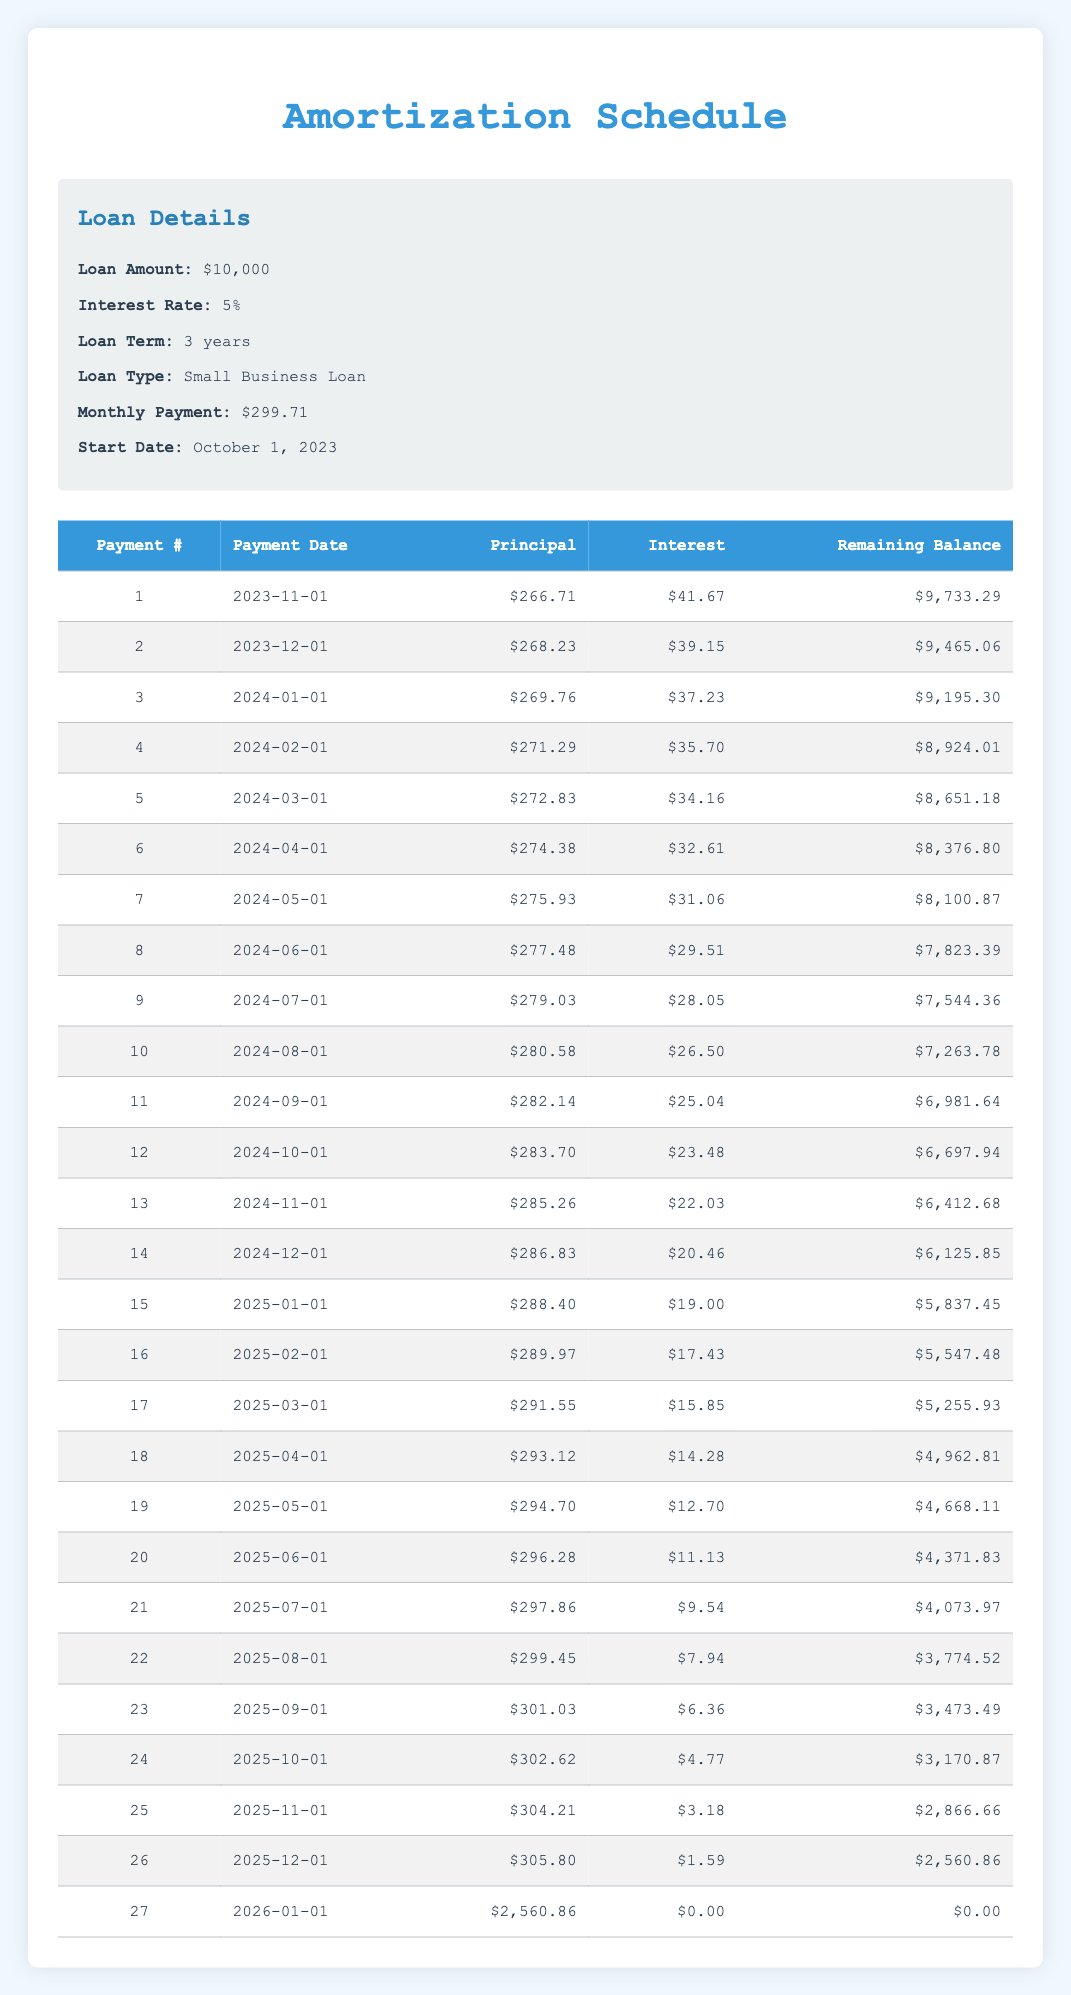What is the total loan amount for the small business loan? The loan amount is listed directly in the loan details section of the table, which states that the loan amount is $10,000.
Answer: $10,000 What is the interest payment for the first month? The first month's interest payment is found in the first row under the interest payment column, which shows $41.67.
Answer: $41.67 What is the remaining balance after the 12th payment? To find the remaining balance after the 12th payment, we look at the corresponding row in the table, which shows a remaining balance of $6,697.94.
Answer: $6,697.94 How much principal is paid in total over the first six months? The total principal payment for the first six months is calculated by summing the principal payments for payments 1 to 6: (266.71 + 268.23 + 269.76 + 271.29 + 272.83 + 274.38) = 1,623.20.
Answer: $1,623.20 Is the last payment date after the loan term ends? The last payment date is January 1, 2026, while the loan term ends on September 30, 2026. Since January 1, 2026 is before September 30, 2026, the statement is true.
Answer: No What was the principal payment in the 15th month? The 15th payment's principal payment is found under the principal column for the row where payment number is 15, which indicates $288.40 was paid towards the principal.
Answer: $288.40 Calculate the average interest payment for the first six months. To find the average, we first sum the interest payments for the first six months: (41.67 + 39.15 + 37.23 + 35.70 + 34.16 + 32.61) = 210.52. Then, we divide by the number of payments (6), giving us 210.52 / 6 = 35.09.
Answer: $35.09 What is the difference in principal payment between the 25th and 24th payments? The principal payments are $304.21 for the 25th payment and $302.62 for the 24th payment. The difference is calculated as (304.21 - 302.62) = 1.59.
Answer: $1.59 Is it true that the monthly payment remains constant throughout the loan term? The monthly payment is shown as a fixed value of $299.71 in the loan details and does not change in the table for any month, indicating that the statement is true.
Answer: Yes 